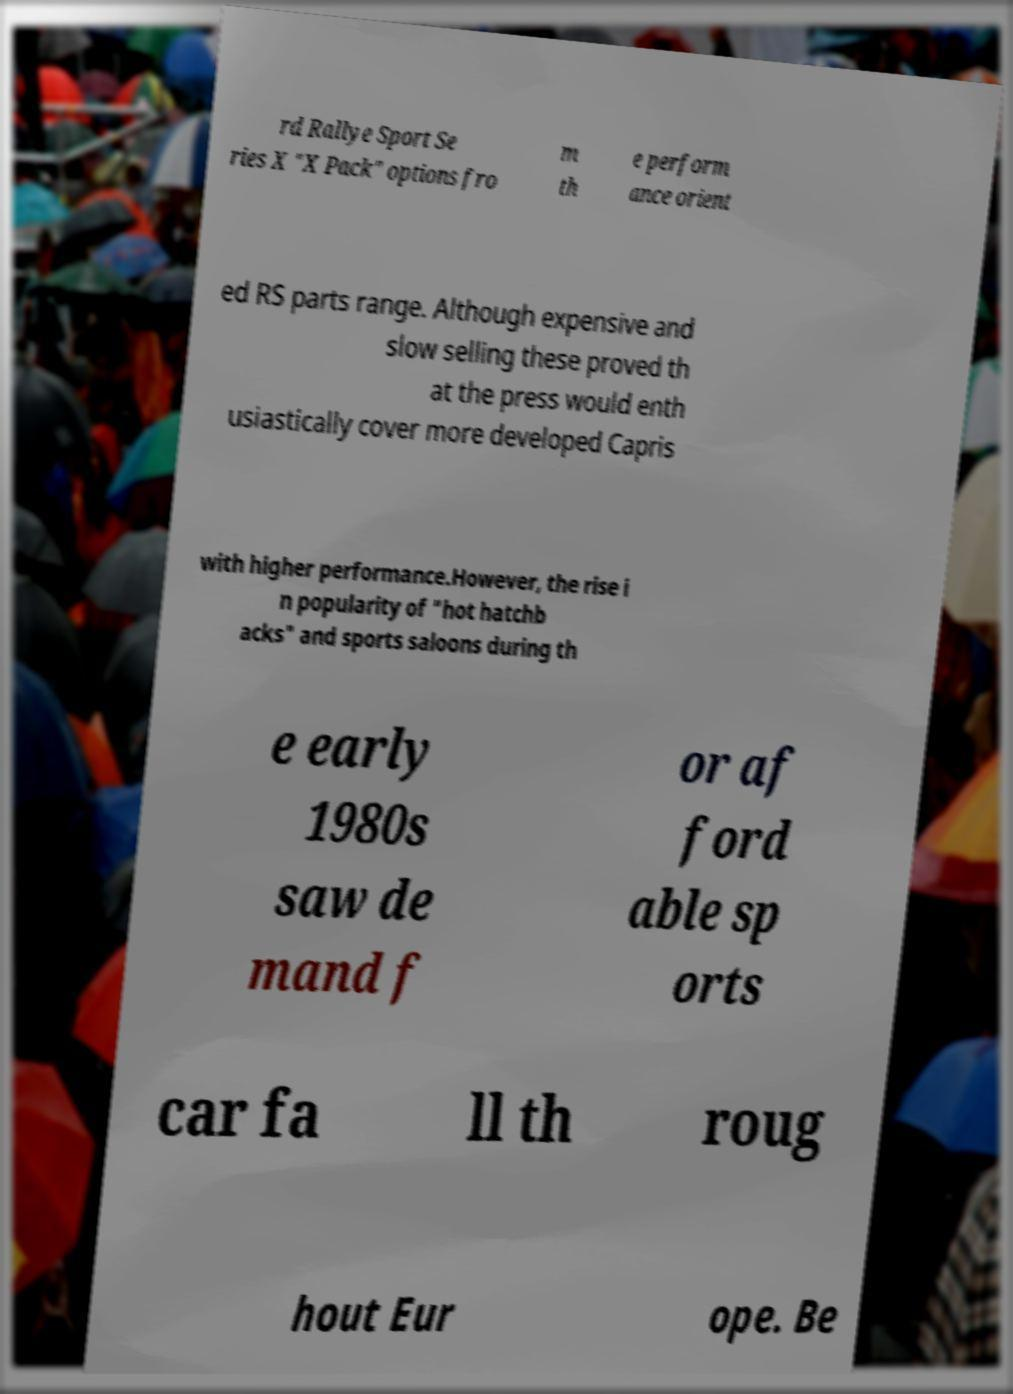Please identify and transcribe the text found in this image. rd Rallye Sport Se ries X "X Pack" options fro m th e perform ance orient ed RS parts range. Although expensive and slow selling these proved th at the press would enth usiastically cover more developed Capris with higher performance.However, the rise i n popularity of "hot hatchb acks" and sports saloons during th e early 1980s saw de mand f or af ford able sp orts car fa ll th roug hout Eur ope. Be 